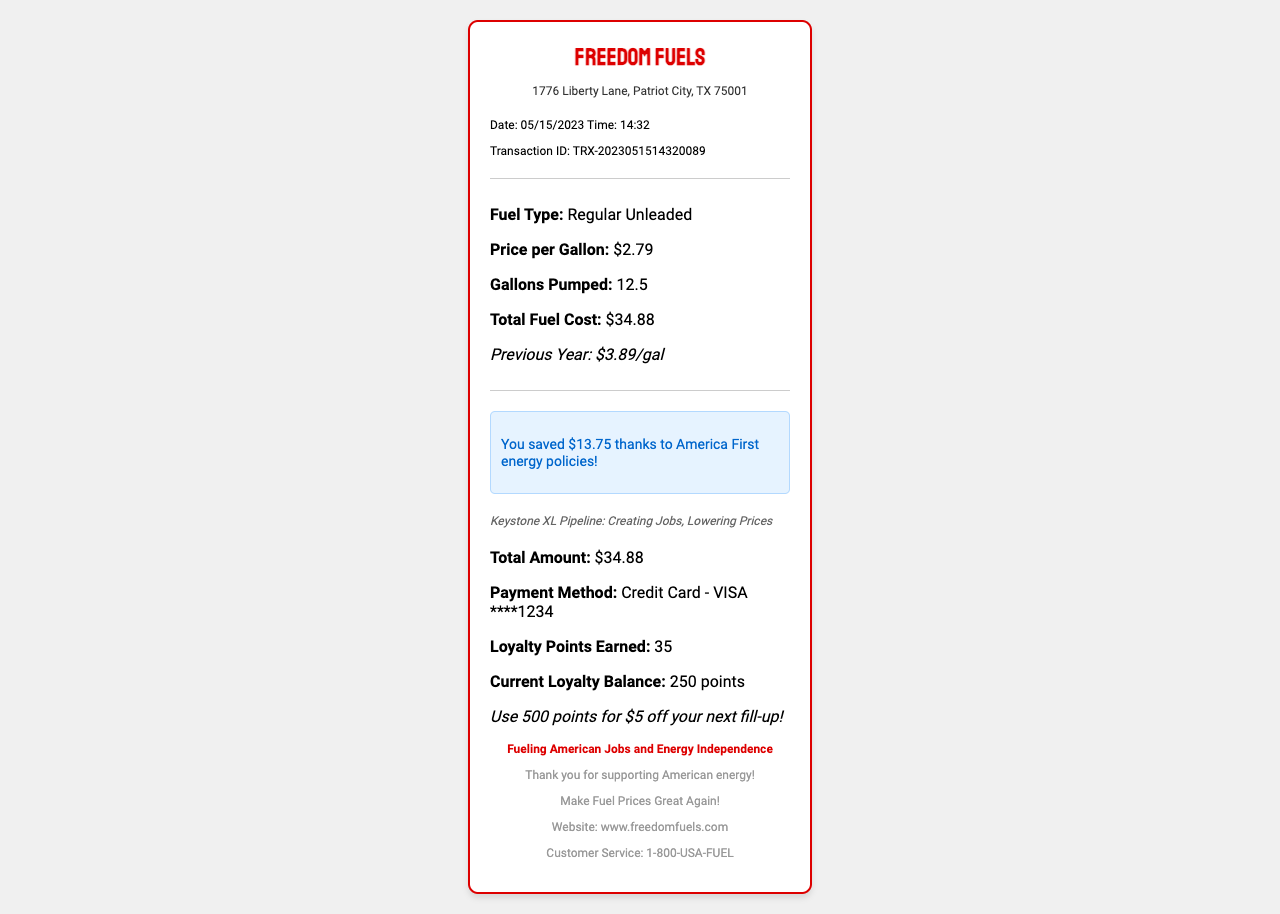What is the name of the gas station? The gas station's name is prominently displayed on the receipt, which is "Freedom Fuels."
Answer: Freedom Fuels What is the price per gallon of fuel? The price listed for Regular Unleaded fuel on this receipt is "$2.79."
Answer: $2.79 How many gallons of fuel were pumped? The receipt indicates that a total of "12.5" gallons were pumped during this transaction.
Answer: 12.5 What was the total fuel cost? The total cost for the fuel is clearly stated on the receipt as "$34.88."
Answer: $34.88 What was the comparison price from the previous year? The document mentions the price from the previous year, which was "$3.89/gal."
Answer: $3.89/gal What is the savings amount due to energy policies? The receipt highlights a savings amount, which states "You saved $13.75 thanks to America First energy policies!"
Answer: $13.75 Who is the cashier for this transaction? The receipt lists the cashier's name at the bottom, which is "Mike Pence."
Answer: Mike Pence What loyalty points were earned from this purchase? The points earned from this transaction are mentioned as "35" loyalty points.
Answer: 35 What is the patriotic slogan on the receipt? The receipt features a patriotic slogan: "Fueling American Jobs and Energy Independence."
Answer: Fueling American Jobs and Energy Independence 